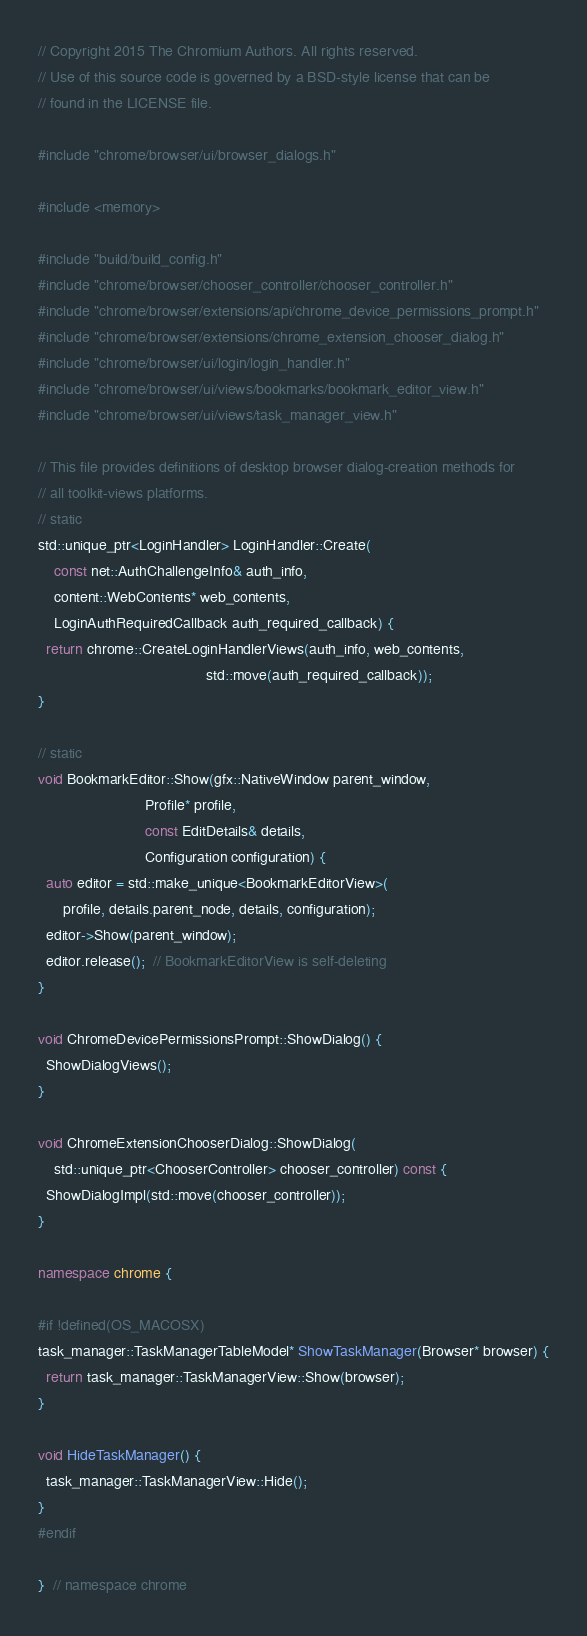Convert code to text. <code><loc_0><loc_0><loc_500><loc_500><_C++_>// Copyright 2015 The Chromium Authors. All rights reserved.
// Use of this source code is governed by a BSD-style license that can be
// found in the LICENSE file.

#include "chrome/browser/ui/browser_dialogs.h"

#include <memory>

#include "build/build_config.h"
#include "chrome/browser/chooser_controller/chooser_controller.h"
#include "chrome/browser/extensions/api/chrome_device_permissions_prompt.h"
#include "chrome/browser/extensions/chrome_extension_chooser_dialog.h"
#include "chrome/browser/ui/login/login_handler.h"
#include "chrome/browser/ui/views/bookmarks/bookmark_editor_view.h"
#include "chrome/browser/ui/views/task_manager_view.h"

// This file provides definitions of desktop browser dialog-creation methods for
// all toolkit-views platforms.
// static
std::unique_ptr<LoginHandler> LoginHandler::Create(
    const net::AuthChallengeInfo& auth_info,
    content::WebContents* web_contents,
    LoginAuthRequiredCallback auth_required_callback) {
  return chrome::CreateLoginHandlerViews(auth_info, web_contents,
                                         std::move(auth_required_callback));
}

// static
void BookmarkEditor::Show(gfx::NativeWindow parent_window,
                          Profile* profile,
                          const EditDetails& details,
                          Configuration configuration) {
  auto editor = std::make_unique<BookmarkEditorView>(
      profile, details.parent_node, details, configuration);
  editor->Show(parent_window);
  editor.release();  // BookmarkEditorView is self-deleting
}

void ChromeDevicePermissionsPrompt::ShowDialog() {
  ShowDialogViews();
}

void ChromeExtensionChooserDialog::ShowDialog(
    std::unique_ptr<ChooserController> chooser_controller) const {
  ShowDialogImpl(std::move(chooser_controller));
}

namespace chrome {

#if !defined(OS_MACOSX)
task_manager::TaskManagerTableModel* ShowTaskManager(Browser* browser) {
  return task_manager::TaskManagerView::Show(browser);
}

void HideTaskManager() {
  task_manager::TaskManagerView::Hide();
}
#endif

}  // namespace chrome
</code> 